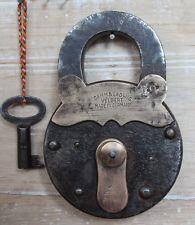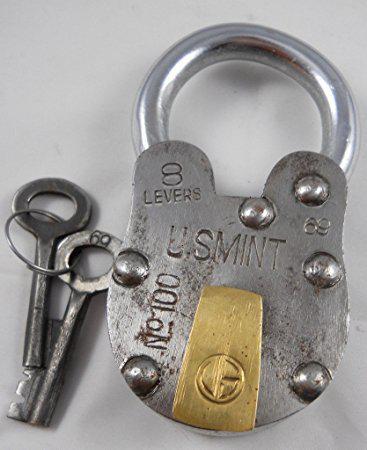The first image is the image on the left, the second image is the image on the right. Assess this claim about the two images: "Both locks are in the lock position.". Correct or not? Answer yes or no. Yes. The first image is the image on the left, the second image is the image on the right. Given the left and right images, does the statement "An image shows one key on a colored string to the left of a vintage lock." hold true? Answer yes or no. Yes. 